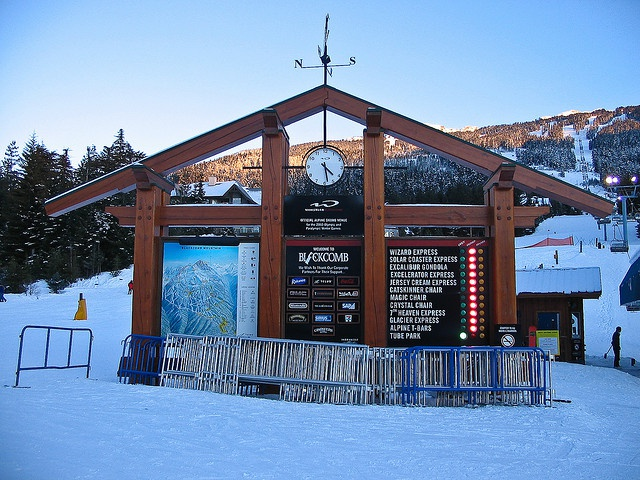Describe the objects in this image and their specific colors. I can see clock in lightblue and gray tones, people in lightblue, black, navy, and purple tones, people in lightblue, black, brown, maroon, and gray tones, and people in lightblue, black, navy, and darkblue tones in this image. 